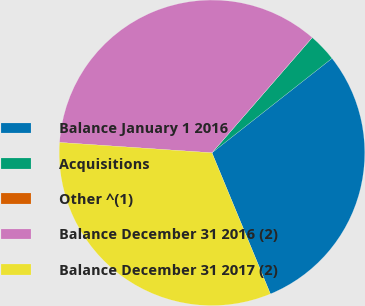Convert chart. <chart><loc_0><loc_0><loc_500><loc_500><pie_chart><fcel>Balance January 1 2016<fcel>Acquisitions<fcel>Other ^(1)<fcel>Balance December 31 2016 (2)<fcel>Balance December 31 2017 (2)<nl><fcel>29.36%<fcel>2.99%<fcel>0.01%<fcel>35.31%<fcel>32.33%<nl></chart> 